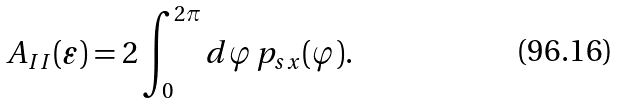<formula> <loc_0><loc_0><loc_500><loc_500>A _ { I I } ( \varepsilon ) = 2 \int _ { 0 } ^ { 2 \pi } d \varphi \, p _ { s x } ( \varphi ) .</formula> 